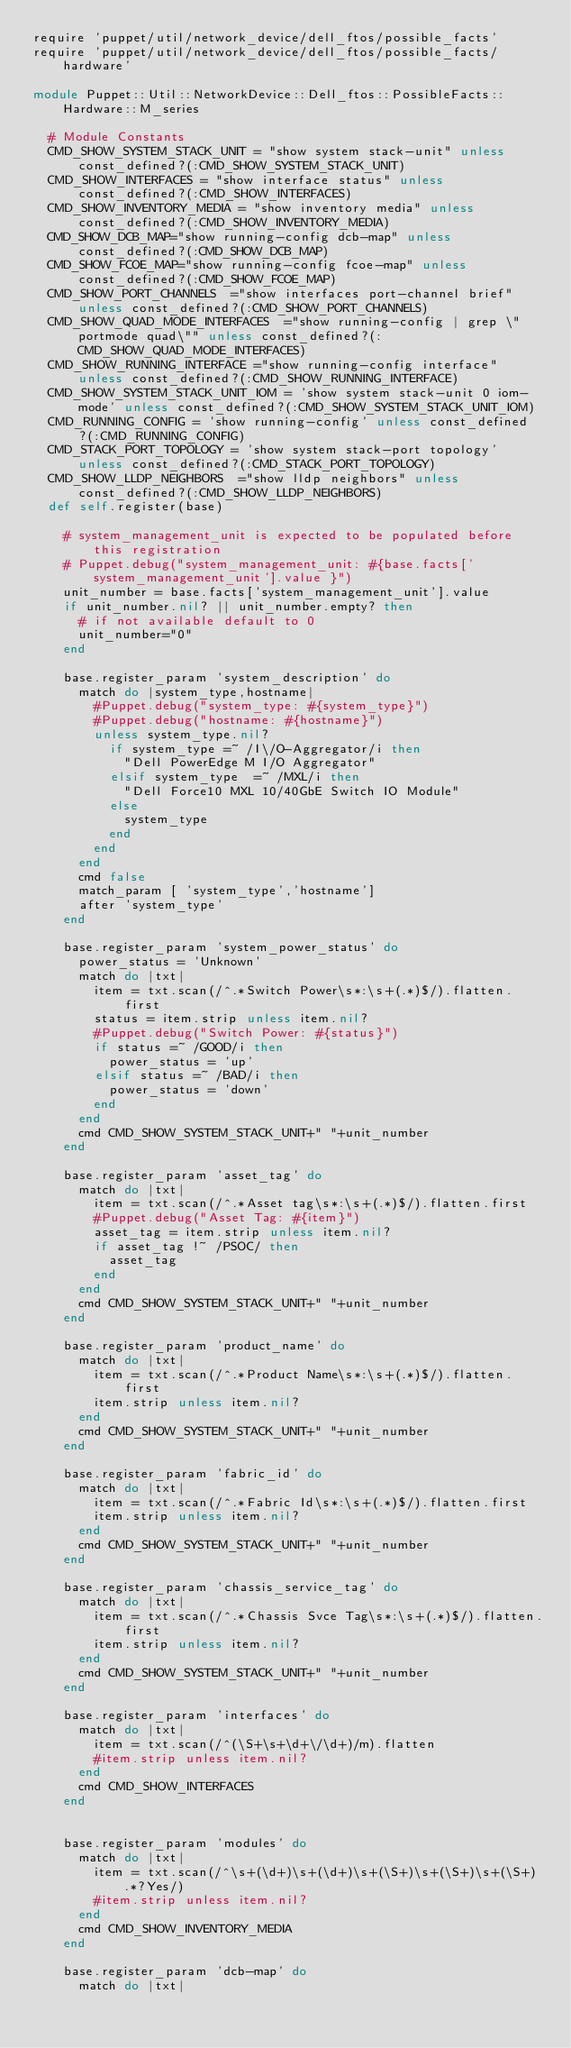Convert code to text. <code><loc_0><loc_0><loc_500><loc_500><_Ruby_>require 'puppet/util/network_device/dell_ftos/possible_facts'
require 'puppet/util/network_device/dell_ftos/possible_facts/hardware'

module Puppet::Util::NetworkDevice::Dell_ftos::PossibleFacts::Hardware::M_series

  # Module Constants
  CMD_SHOW_SYSTEM_STACK_UNIT = "show system stack-unit" unless const_defined?(:CMD_SHOW_SYSTEM_STACK_UNIT)
  CMD_SHOW_INTERFACES = "show interface status" unless const_defined?(:CMD_SHOW_INTERFACES) 
  CMD_SHOW_INVENTORY_MEDIA = "show inventory media" unless const_defined?(:CMD_SHOW_INVENTORY_MEDIA) 
  CMD_SHOW_DCB_MAP="show running-config dcb-map" unless const_defined?(:CMD_SHOW_DCB_MAP)
  CMD_SHOW_FCOE_MAP="show running-config fcoe-map" unless const_defined?(:CMD_SHOW_FCOE_MAP)  
  CMD_SHOW_PORT_CHANNELS  ="show interfaces port-channel brief" unless const_defined?(:CMD_SHOW_PORT_CHANNELS) 
  CMD_SHOW_QUAD_MODE_INTERFACES  ="show running-config | grep \"portmode quad\"" unless const_defined?(:CMD_SHOW_QUAD_MODE_INTERFACES)  
  CMD_SHOW_RUNNING_INTERFACE ="show running-config interface" unless const_defined?(:CMD_SHOW_RUNNING_INTERFACE) 
  CMD_SHOW_SYSTEM_STACK_UNIT_IOM = 'show system stack-unit 0 iom-mode' unless const_defined?(:CMD_SHOW_SYSTEM_STACK_UNIT_IOM)
  CMD_RUNNING_CONFIG = 'show running-config' unless const_defined?(:CMD_RUNNING_CONFIG)
  CMD_STACK_PORT_TOPOLOGY = 'show system stack-port topology' unless const_defined?(:CMD_STACK_PORT_TOPOLOGY)
  CMD_SHOW_LLDP_NEIGHBORS  ="show lldp neighbors" unless const_defined?(:CMD_SHOW_LLDP_NEIGHBORS)
  def self.register(base)

    # system_management_unit is expected to be populated before this registration
    # Puppet.debug("system_management_unit: #{base.facts['system_management_unit'].value }")
    unit_number = base.facts['system_management_unit'].value
    if unit_number.nil? || unit_number.empty? then
      # if not available default to 0
      unit_number="0"
    end

    base.register_param 'system_description' do
      match do |system_type,hostname|
        #Puppet.debug("system_type: #{system_type}")
        #Puppet.debug("hostname: #{hostname}")
        unless system_type.nil?
          if system_type =~ /I\/O-Aggregator/i then
            "Dell PowerEdge M I/O Aggregator"
          elsif system_type  =~ /MXL/i then
            "Dell Force10 MXL 10/40GbE Switch IO Module"
          else
            system_type
          end
        end
      end
      cmd false
      match_param [ 'system_type','hostname']
      after 'system_type'
    end

    base.register_param 'system_power_status' do
      power_status = 'Unknown'
      match do |txt|
        item = txt.scan(/^.*Switch Power\s*:\s+(.*)$/).flatten.first
        status = item.strip unless item.nil?
        #Puppet.debug("Switch Power: #{status}")
        if status =~ /GOOD/i then
          power_status = 'up'
        elsif status =~ /BAD/i then
          power_status = 'down'
        end
      end
      cmd CMD_SHOW_SYSTEM_STACK_UNIT+" "+unit_number
    end

    base.register_param 'asset_tag' do
      match do |txt|
        item = txt.scan(/^.*Asset tag\s*:\s+(.*)$/).flatten.first
        #Puppet.debug("Asset Tag: #{item}")
        asset_tag = item.strip unless item.nil?
        if asset_tag !~ /PSOC/ then
          asset_tag
        end
      end
      cmd CMD_SHOW_SYSTEM_STACK_UNIT+" "+unit_number
    end

    base.register_param 'product_name' do
      match do |txt|
        item = txt.scan(/^.*Product Name\s*:\s+(.*)$/).flatten.first
        item.strip unless item.nil?
      end
      cmd CMD_SHOW_SYSTEM_STACK_UNIT+" "+unit_number
    end

    base.register_param 'fabric_id' do
      match do |txt|
        item = txt.scan(/^.*Fabric Id\s*:\s+(.*)$/).flatten.first
        item.strip unless item.nil?
      end
      cmd CMD_SHOW_SYSTEM_STACK_UNIT+" "+unit_number
    end

    base.register_param 'chassis_service_tag' do
      match do |txt|
        item = txt.scan(/^.*Chassis Svce Tag\s*:\s+(.*)$/).flatten.first
        item.strip unless item.nil?
      end
      cmd CMD_SHOW_SYSTEM_STACK_UNIT+" "+unit_number
    end
    
    base.register_param 'interfaces' do
      match do |txt|
        item = txt.scan(/^(\S+\s+\d+\/\d+)/m).flatten
        #item.strip unless item.nil?
      end
      cmd CMD_SHOW_INTERFACES
    end
    
    
    base.register_param 'modules' do
      match do |txt|
        item = txt.scan(/^\s+(\d+)\s+(\d+)\s+(\S+)\s+(\S+)\s+(\S+).*?Yes/)
        #item.strip unless item.nil?
      end
      cmd CMD_SHOW_INVENTORY_MEDIA
    end
    
    base.register_param 'dcb-map' do
      match do |txt|</code> 